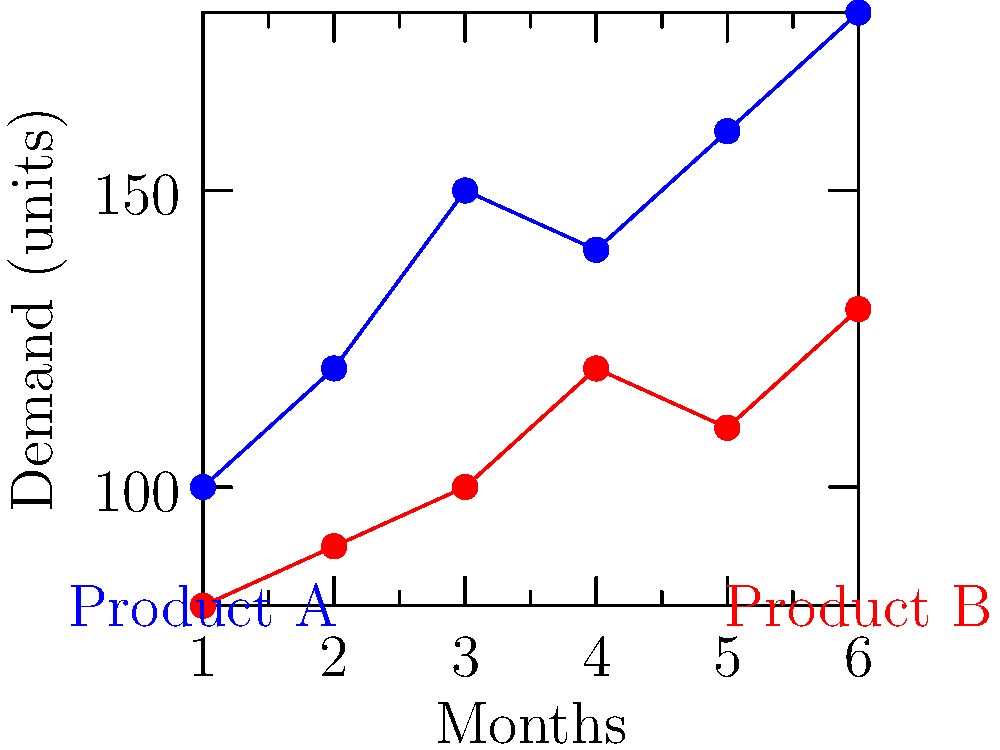As a textile manufacturer, you're analyzing market demand trends for two products over a six-month period. The blue line represents Product A, and the red line represents Product B. Based on the graph, which product shows a more consistent upward trend in demand, and what might this suggest about future production planning? To answer this question, let's analyze the demand trends for both products:

1. Product A (Blue line):
   - Starts at 100 units in month 1
   - Increases to 120 units in month 2
   - Rises to 150 units in month 3
   - Slight dip to 140 units in month 4
   - Increases again to 160 units in month 5
   - Ends at 180 units in month 6

2. Product B (Red line):
   - Starts at 80 units in month 1
   - Gradual increase to 90, 100, and 120 units in months 2, 3, and 4
   - Slight dip to 110 units in month 5
   - Ends at 130 units in month 6

3. Comparing the trends:
   - Product A shows a steeper overall increase from 100 to 180 units
   - Product B shows a more gradual increase from 80 to 130 units
   - Both products have one slight dip in demand, but recover afterward

4. Consistency of upward trend:
   - Product A has larger fluctuations but a stronger overall upward trend
   - Product B has a more consistent, gradual upward trend with smaller fluctuations

5. Implications for future production planning:
   - Product A may require more flexible production capacity to handle larger demand swings
   - Product B might allow for more stable production planning due to its consistent growth

While both products show an upward trend, Product B demonstrates a more consistent upward trend in demand. This suggests that future production planning for Product B could be more predictable and easier to manage in terms of resource allocation and inventory control.
Answer: Product B; more predictable production planning 